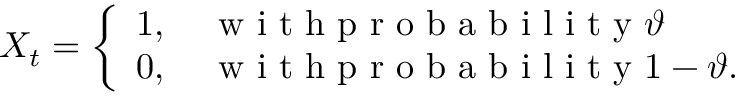<formula> <loc_0><loc_0><loc_500><loc_500>X _ { t } = \left \{ \begin{array} { l l } { 1 , \quad w i t h p r o b a b i l i t y \vartheta } \\ { 0 , \quad w i t h p r o b a b i l i t y 1 - \vartheta . } \end{array}</formula> 